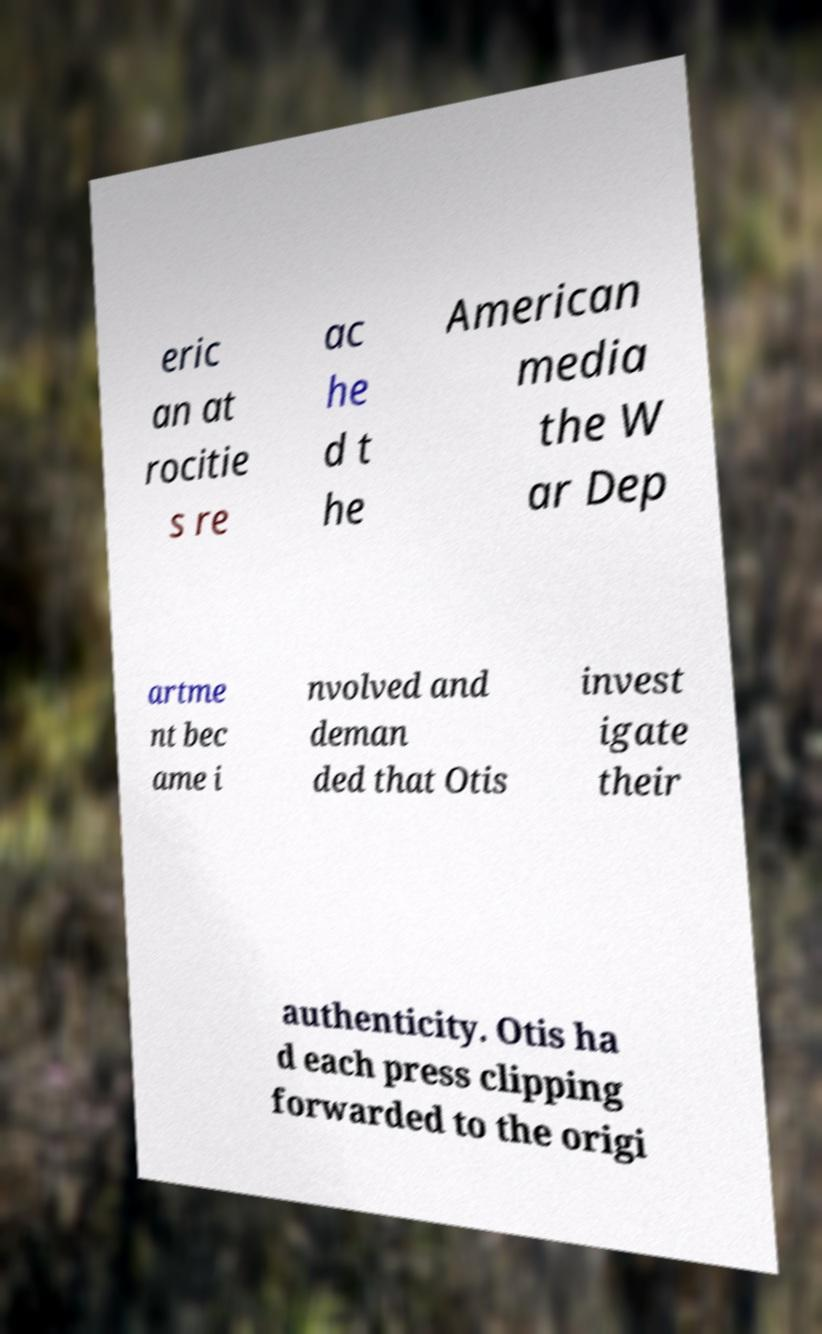Can you accurately transcribe the text from the provided image for me? eric an at rocitie s re ac he d t he American media the W ar Dep artme nt bec ame i nvolved and deman ded that Otis invest igate their authenticity. Otis ha d each press clipping forwarded to the origi 